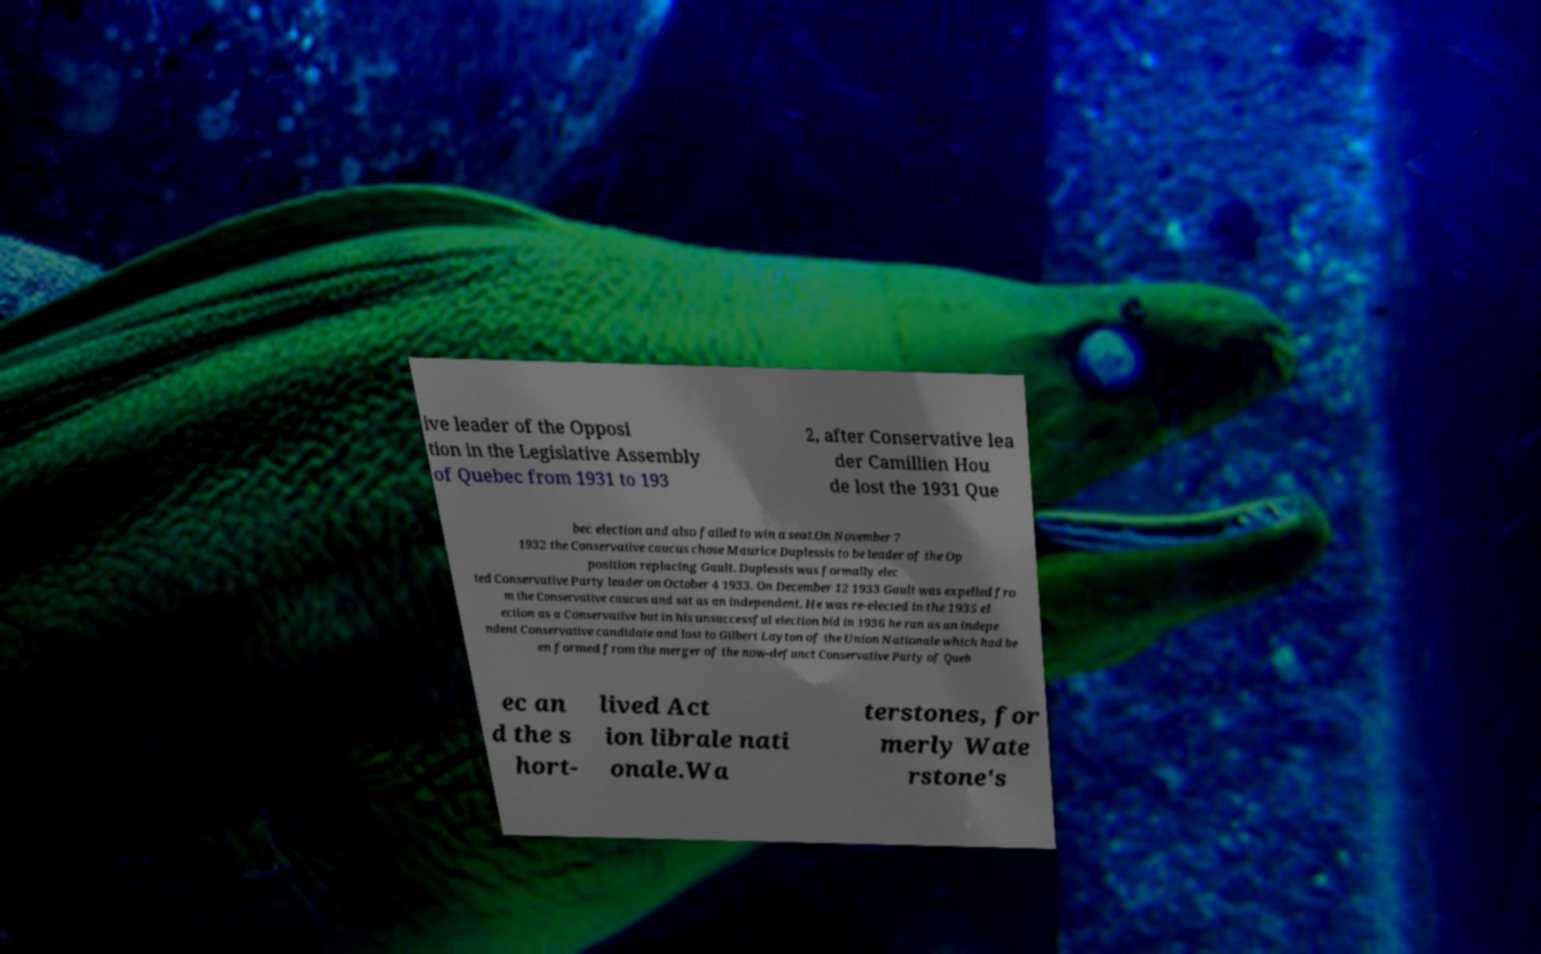I need the written content from this picture converted into text. Can you do that? ive leader of the Opposi tion in the Legislative Assembly of Quebec from 1931 to 193 2, after Conservative lea der Camillien Hou de lost the 1931 Que bec election and also failed to win a seat.On November 7 1932 the Conservative caucus chose Maurice Duplessis to be leader of the Op position replacing Gault. Duplessis was formally elec ted Conservative Party leader on October 4 1933. On December 12 1933 Gault was expelled fro m the Conservative caucus and sat as an independent. He was re-elected in the 1935 el ection as a Conservative but in his unsuccessful election bid in 1936 he ran as an indepe ndent Conservative candidate and lost to Gilbert Layton of the Union Nationale which had be en formed from the merger of the now-defunct Conservative Party of Queb ec an d the s hort- lived Act ion librale nati onale.Wa terstones, for merly Wate rstone's 